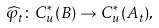Convert formula to latex. <formula><loc_0><loc_0><loc_500><loc_500>\widehat { \varphi } _ { t } \colon C _ { u } ^ { \ast } ( B ) \rightarrow C _ { u } ^ { \ast } ( A _ { t } ) ,</formula> 